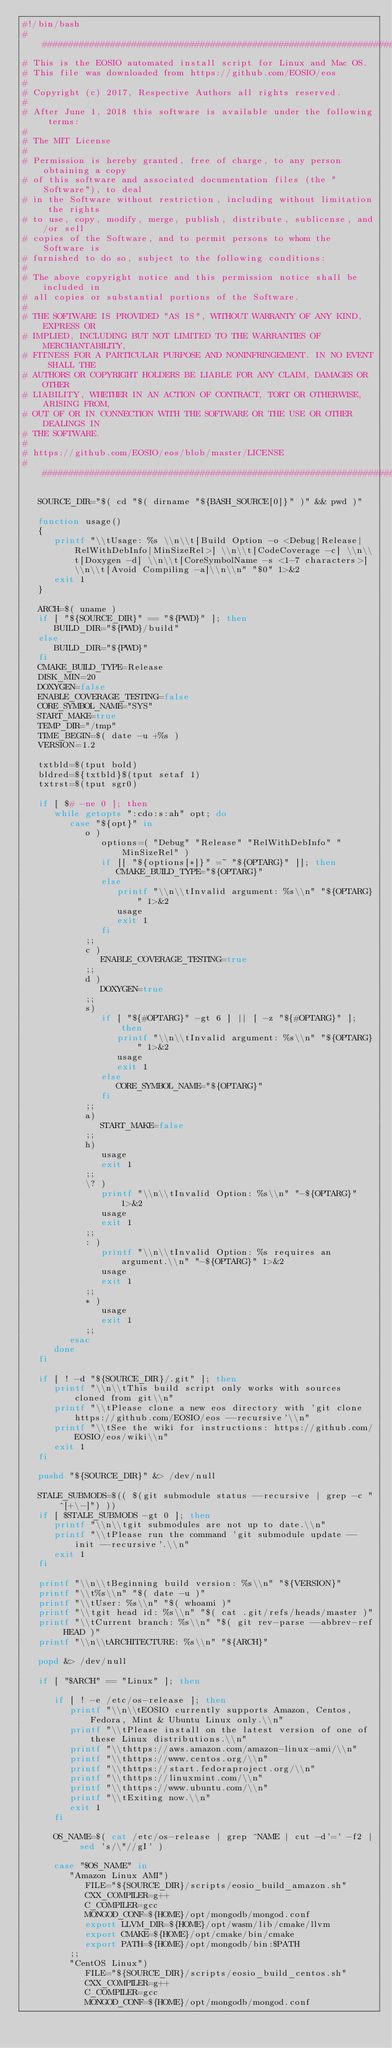Convert code to text. <code><loc_0><loc_0><loc_500><loc_500><_Bash_>#!/bin/bash
##########################################################################
# This is the EOSIO automated install script for Linux and Mac OS.
# This file was downloaded from https://github.com/EOSIO/eos
#
# Copyright (c) 2017, Respective Authors all rights reserved.
#
# After June 1, 2018 this software is available under the following terms:
#
# The MIT License
#
# Permission is hereby granted, free of charge, to any person obtaining a copy
# of this software and associated documentation files (the "Software"), to deal
# in the Software without restriction, including without limitation the rights
# to use, copy, modify, merge, publish, distribute, sublicense, and/or sell
# copies of the Software, and to permit persons to whom the Software is
# furnished to do so, subject to the following conditions:
#
# The above copyright notice and this permission notice shall be included in
# all copies or substantial portions of the Software.
#
# THE SOFTWARE IS PROVIDED "AS IS", WITHOUT WARRANTY OF ANY KIND, EXPRESS OR
# IMPLIED, INCLUDING BUT NOT LIMITED TO THE WARRANTIES OF MERCHANTABILITY,
# FITNESS FOR A PARTICULAR PURPOSE AND NONINFRINGEMENT. IN NO EVENT SHALL THE
# AUTHORS OR COPYRIGHT HOLDERS BE LIABLE FOR ANY CLAIM, DAMAGES OR OTHER
# LIABILITY, WHETHER IN AN ACTION OF CONTRACT, TORT OR OTHERWISE, ARISING FROM,
# OUT OF OR IN CONNECTION WITH THE SOFTWARE OR THE USE OR OTHER DEALINGS IN
# THE SOFTWARE.
#
# https://github.com/EOSIO/eos/blob/master/LICENSE
##########################################################################

   SOURCE_DIR="$( cd "$( dirname "${BASH_SOURCE[0]}" )" && pwd )"

   function usage()
   {
      printf "\\tUsage: %s \\n\\t[Build Option -o <Debug|Release|RelWithDebInfo|MinSizeRel>] \\n\\t[CodeCoverage -c] \\n\\t[Doxygen -d] \\n\\t[CoreSymbolName -s <1-7 characters>] \\n\\t[Avoid Compiling -a]\\n\\n" "$0" 1>&2
      exit 1
   }

   ARCH=$( uname )
   if [ "${SOURCE_DIR}" == "${PWD}" ]; then
      BUILD_DIR="${PWD}/build"
   else
      BUILD_DIR="${PWD}"
   fi
   CMAKE_BUILD_TYPE=Release
   DISK_MIN=20
   DOXYGEN=false
   ENABLE_COVERAGE_TESTING=false
   CORE_SYMBOL_NAME="SYS"
   START_MAKE=true
   TEMP_DIR="/tmp"
   TIME_BEGIN=$( date -u +%s )
   VERSION=1.2

   txtbld=$(tput bold)
   bldred=${txtbld}$(tput setaf 1)
   txtrst=$(tput sgr0)

   if [ $# -ne 0 ]; then
      while getopts ":cdo:s:ah" opt; do
         case "${opt}" in
            o )
               options=( "Debug" "Release" "RelWithDebInfo" "MinSizeRel" )
               if [[ "${options[*]}" =~ "${OPTARG}" ]]; then
                  CMAKE_BUILD_TYPE="${OPTARG}"
               else
                  printf "\\n\\tInvalid argument: %s\\n" "${OPTARG}" 1>&2
                  usage
                  exit 1
               fi
            ;;
            c )
               ENABLE_COVERAGE_TESTING=true
            ;;
            d )
               DOXYGEN=true
            ;;
            s)
               if [ "${#OPTARG}" -gt 6 ] || [ -z "${#OPTARG}" ]; then
                  printf "\\n\\tInvalid argument: %s\\n" "${OPTARG}" 1>&2
                  usage
                  exit 1
               else
                  CORE_SYMBOL_NAME="${OPTARG}"
               fi
            ;;
            a)
               START_MAKE=false
            ;;
            h)
               usage
               exit 1
            ;;
            \? )
               printf "\\n\\tInvalid Option: %s\\n" "-${OPTARG}" 1>&2
               usage
               exit 1
            ;;
            : )
               printf "\\n\\tInvalid Option: %s requires an argument.\\n" "-${OPTARG}" 1>&2
               usage
               exit 1
            ;;
            * )
               usage
               exit 1
            ;;
         esac
      done
   fi

   if [ ! -d "${SOURCE_DIR}/.git" ]; then
      printf "\\n\\tThis build script only works with sources cloned from git\\n"
      printf "\\tPlease clone a new eos directory with 'git clone https://github.com/EOSIO/eos --recursive'\\n"
      printf "\\tSee the wiki for instructions: https://github.com/EOSIO/eos/wiki\\n"
      exit 1
   fi

   pushd "${SOURCE_DIR}" &> /dev/null

   STALE_SUBMODS=$(( $(git submodule status --recursive | grep -c "^[+\-]") ))
   if [ $STALE_SUBMODS -gt 0 ]; then
      printf "\\n\\tgit submodules are not up to date.\\n"
      printf "\\tPlease run the command 'git submodule update --init --recursive'.\\n"
      exit 1
   fi

   printf "\\n\\tBeginning build version: %s\\n" "${VERSION}"
   printf "\\t%s\\n" "$( date -u )"
   printf "\\tUser: %s\\n" "$( whoami )"
   printf "\\tgit head id: %s\\n" "$( cat .git/refs/heads/master )"
   printf "\\tCurrent branch: %s\\n" "$( git rev-parse --abbrev-ref HEAD )"
   printf "\\n\\tARCHITECTURE: %s\\n" "${ARCH}"

   popd &> /dev/null

   if [ "$ARCH" == "Linux" ]; then

      if [ ! -e /etc/os-release ]; then
         printf "\\n\\tEOSIO currently supports Amazon, Centos, Fedora, Mint & Ubuntu Linux only.\\n"
         printf "\\tPlease install on the latest version of one of these Linux distributions.\\n"
         printf "\\thttps://aws.amazon.com/amazon-linux-ami/\\n"
         printf "\\thttps://www.centos.org/\\n"
         printf "\\thttps://start.fedoraproject.org/\\n"
         printf "\\thttps://linuxmint.com/\\n"
         printf "\\thttps://www.ubuntu.com/\\n"
         printf "\\tExiting now.\\n"
         exit 1
      fi

      OS_NAME=$( cat /etc/os-release | grep ^NAME | cut -d'=' -f2 | sed 's/\"//gI' )

      case "$OS_NAME" in
         "Amazon Linux AMI")
            FILE="${SOURCE_DIR}/scripts/eosio_build_amazon.sh"
            CXX_COMPILER=g++
            C_COMPILER=gcc
            MONGOD_CONF=${HOME}/opt/mongodb/mongod.conf
            export LLVM_DIR=${HOME}/opt/wasm/lib/cmake/llvm
            export CMAKE=${HOME}/opt/cmake/bin/cmake
            export PATH=${HOME}/opt/mongodb/bin:$PATH
         ;;
         "CentOS Linux")
            FILE="${SOURCE_DIR}/scripts/eosio_build_centos.sh"
            CXX_COMPILER=g++
            C_COMPILER=gcc
            MONGOD_CONF=${HOME}/opt/mongodb/mongod.conf</code> 